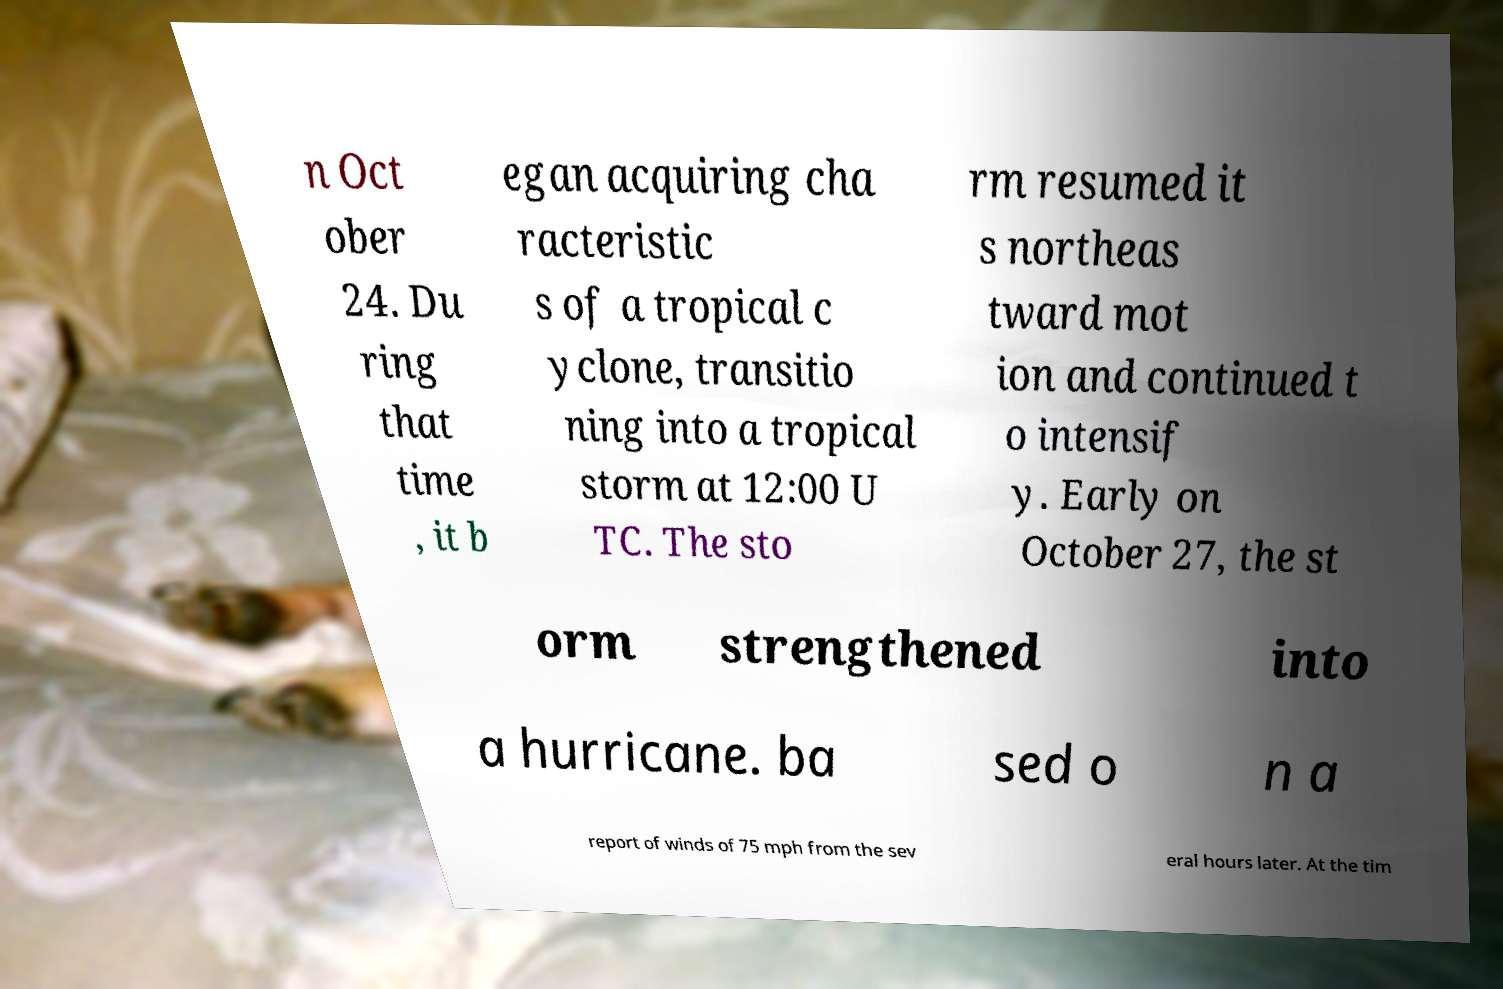Could you extract and type out the text from this image? n Oct ober 24. Du ring that time , it b egan acquiring cha racteristic s of a tropical c yclone, transitio ning into a tropical storm at 12:00 U TC. The sto rm resumed it s northeas tward mot ion and continued t o intensif y. Early on October 27, the st orm strengthened into a hurricane. ba sed o n a report of winds of 75 mph from the sev eral hours later. At the tim 